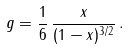<formula> <loc_0><loc_0><loc_500><loc_500>g = \frac { 1 } { 6 } \, \frac { x } { ( 1 - x ) ^ { 3 / 2 } } \, .</formula> 